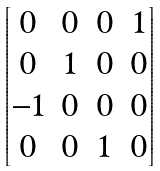Convert formula to latex. <formula><loc_0><loc_0><loc_500><loc_500>\begin{bmatrix} 0 & 0 & 0 & 1 \\ 0 & 1 & 0 & 0 \\ - 1 & 0 & 0 & 0 \\ 0 & 0 & 1 & 0 \end{bmatrix}</formula> 